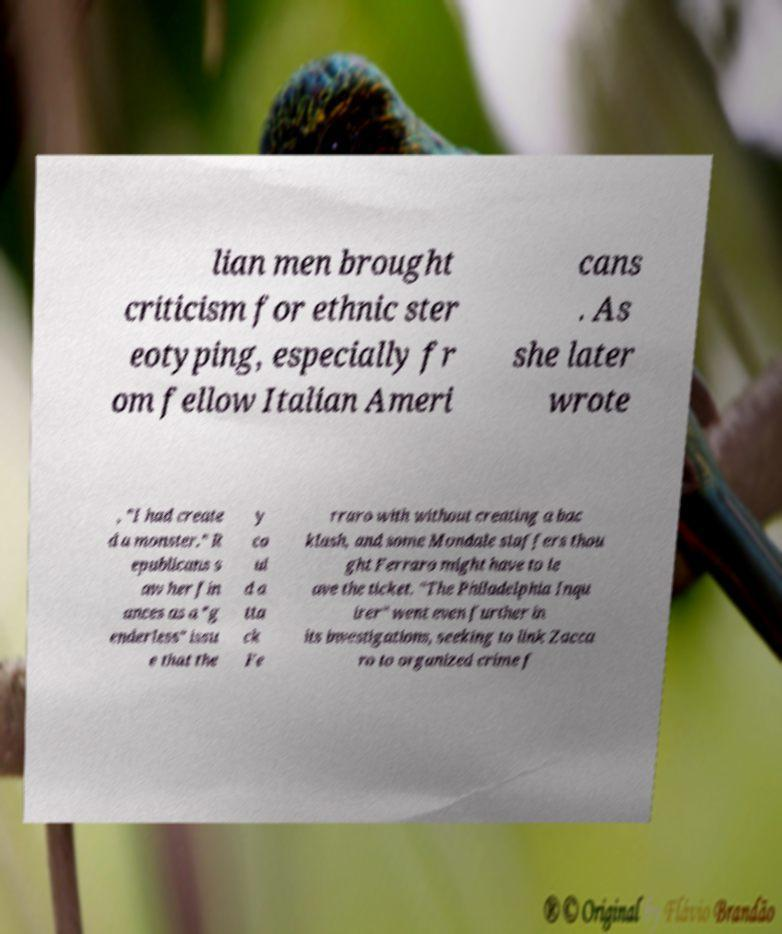Could you assist in decoding the text presented in this image and type it out clearly? lian men brought criticism for ethnic ster eotyping, especially fr om fellow Italian Ameri cans . As she later wrote , "I had create d a monster." R epublicans s aw her fin ances as a "g enderless" issu e that the y co ul d a tta ck Fe rraro with without creating a bac klash, and some Mondale staffers thou ght Ferraro might have to le ave the ticket. "The Philadelphia Inqu irer" went even further in its investigations, seeking to link Zacca ro to organized crime f 